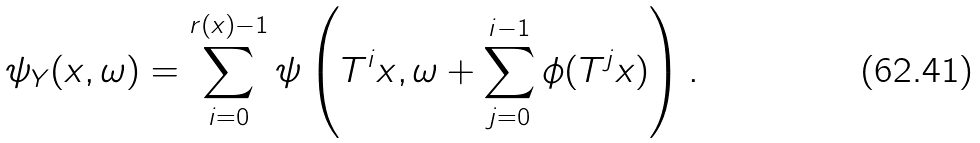<formula> <loc_0><loc_0><loc_500><loc_500>\psi _ { Y } ( x , \omega ) = \sum _ { i = 0 } ^ { r ( x ) - 1 } \psi \left ( T ^ { i } x , \omega + \sum _ { j = 0 } ^ { i - 1 } \phi ( T ^ { j } x ) \right ) .</formula> 